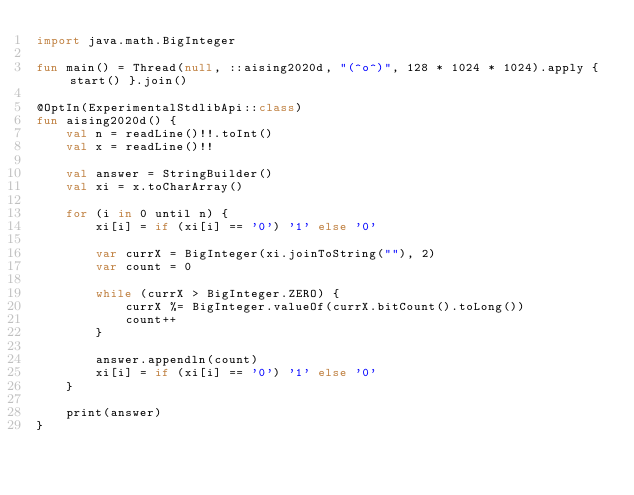<code> <loc_0><loc_0><loc_500><loc_500><_Kotlin_>import java.math.BigInteger

fun main() = Thread(null, ::aising2020d, "(^o^)", 128 * 1024 * 1024).apply { start() }.join()

@OptIn(ExperimentalStdlibApi::class)
fun aising2020d() {
    val n = readLine()!!.toInt()
    val x = readLine()!!

    val answer = StringBuilder()
    val xi = x.toCharArray()

    for (i in 0 until n) {
        xi[i] = if (xi[i] == '0') '1' else '0'

        var currX = BigInteger(xi.joinToString(""), 2)
        var count = 0

        while (currX > BigInteger.ZERO) {
            currX %= BigInteger.valueOf(currX.bitCount().toLong())
            count++
        }

        answer.appendln(count)
        xi[i] = if (xi[i] == '0') '1' else '0'
    }

    print(answer)
}
</code> 